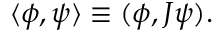<formula> <loc_0><loc_0><loc_500><loc_500>\langle \phi , \psi \rangle \equiv ( \phi , J \psi ) .</formula> 